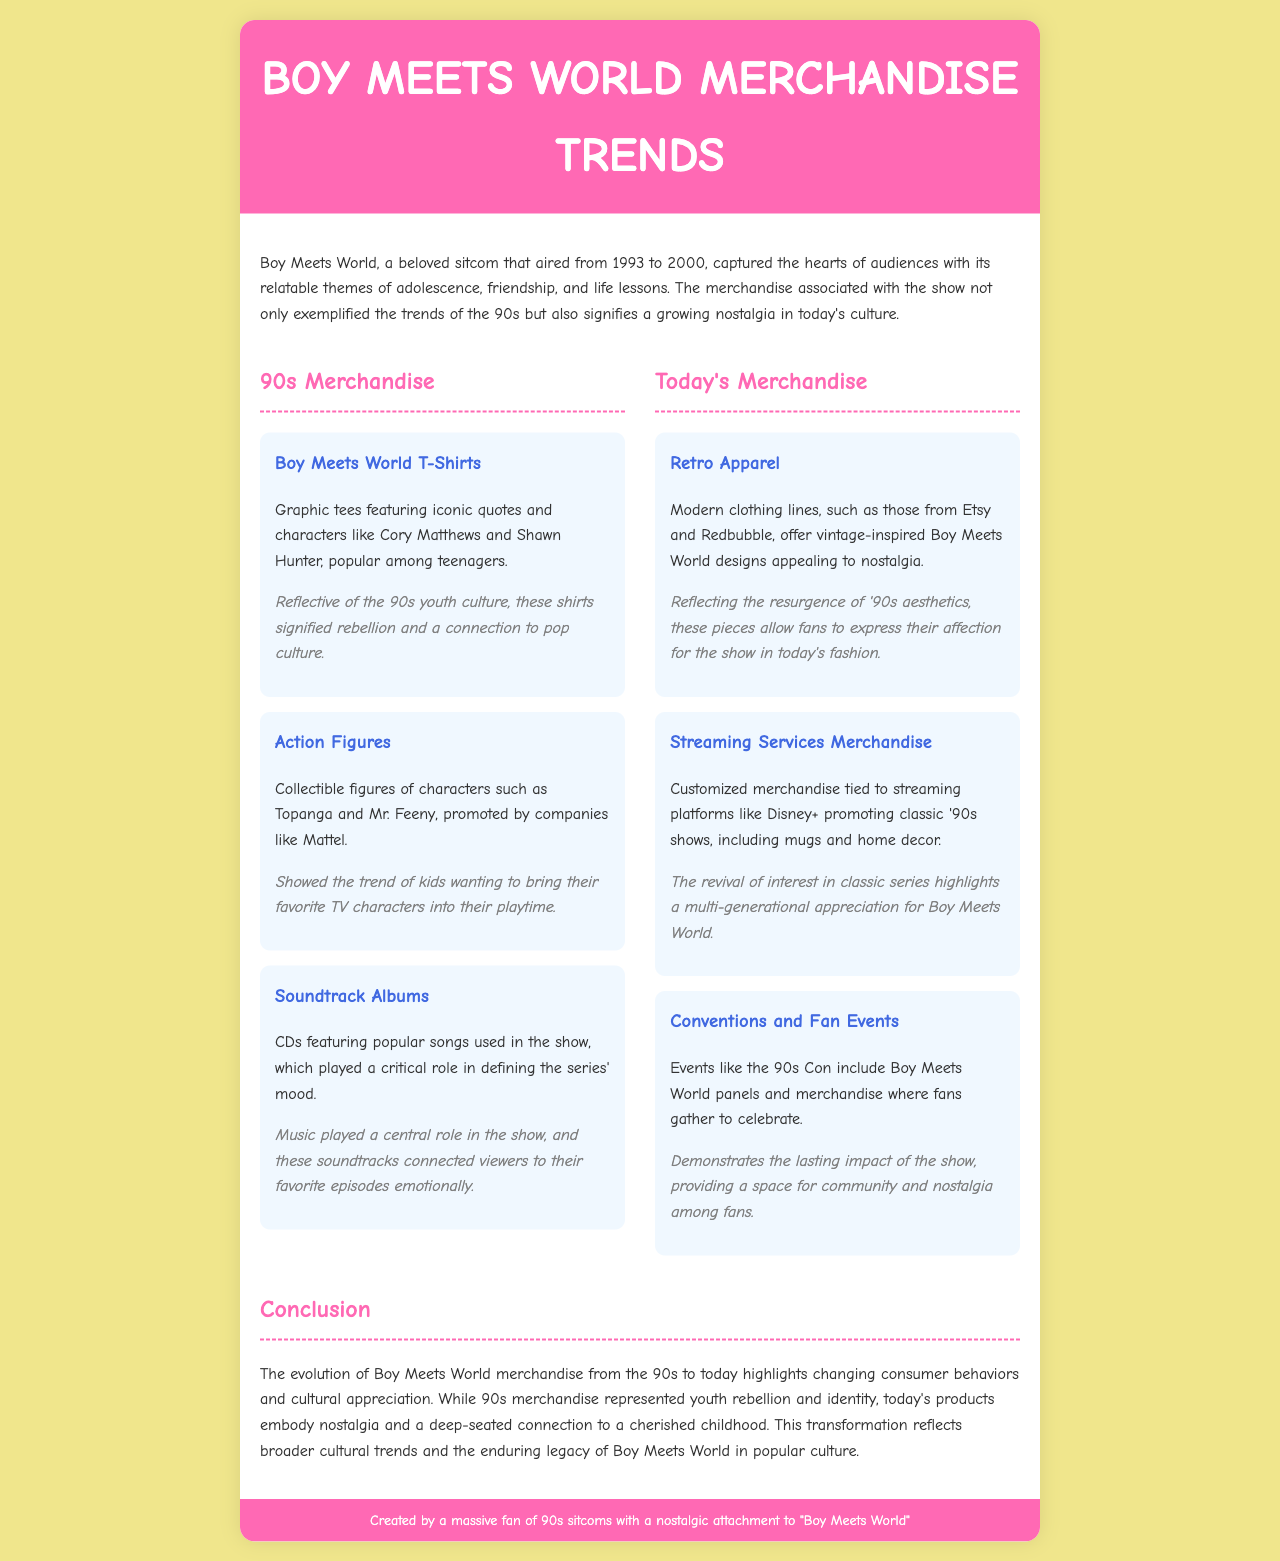What year did Boy Meets World air? Boy Meets World aired from 1993 to 2000 as stated in the introduction.
Answer: 1993 to 2000 What type of merchandise featured Cory Matthews and Shawn Hunter? The document mentions graphic tees featuring these characters.
Answer: T-Shirts Which company promoted collectible figures of Boy Meets World characters? The document specifies Mattel as the company that promoted these figures.
Answer: Mattel What modern clothing lines offer vintage-inspired Boy Meets World designs? The document states that Etsy and Redbubble offer these designs.
Answer: Etsy and Redbubble What does today's retro apparel merchandise reflect? The significance section discusses how it reflects the resurgence of '90s aesthetics.
Answer: 90s aesthetics What type of event includes Boy Meets World panels? The document mentions events like the 90s Con that include these panels.
Answer: 90s Con How has the merchandise evolved from the 90s to today? The conclusion summarizes this by discussing changing consumer behaviors and cultural appreciation.
Answer: Changing consumer behaviors What is the cultural significance of Boy Meets World merchandise today? The document highlights that today's products embody nostalgia and a deep-seated connection to childhood.
Answer: Nostalgia and connection to childhood 